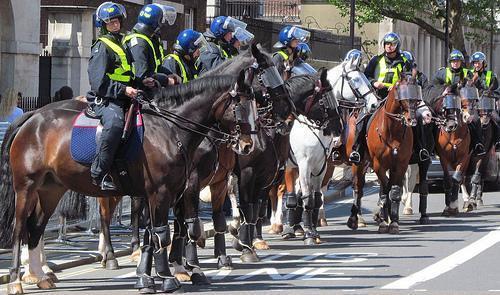How many officers in picture?
Give a very brief answer. 11. 